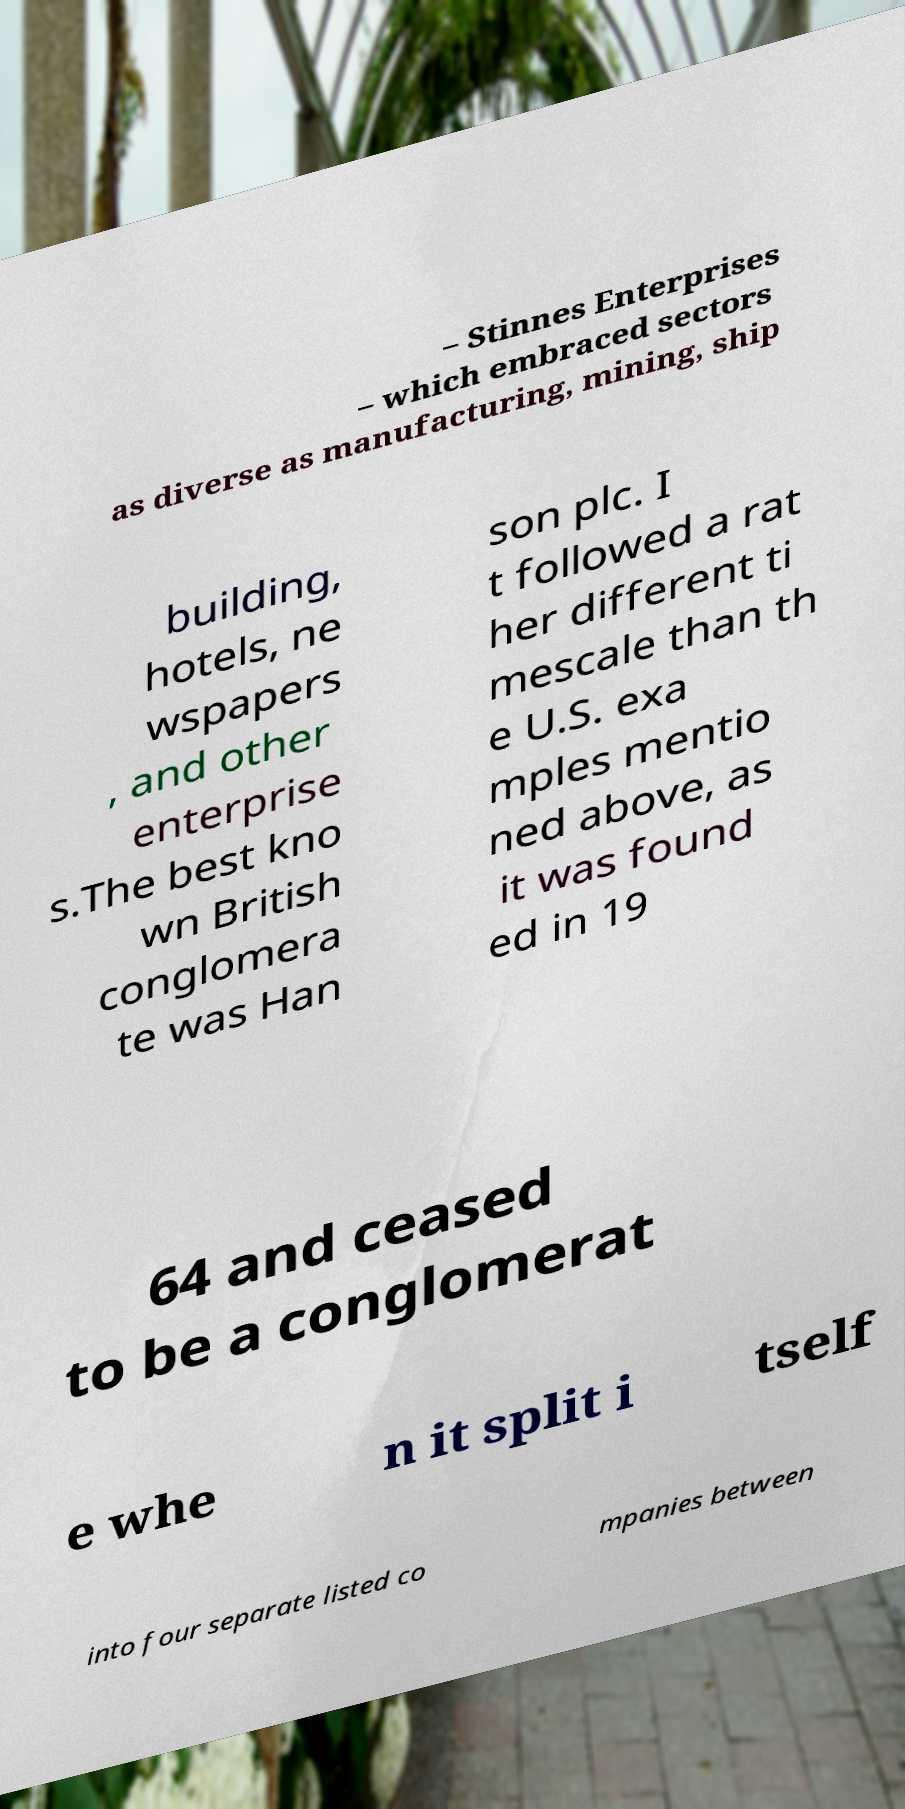There's text embedded in this image that I need extracted. Can you transcribe it verbatim? – Stinnes Enterprises – which embraced sectors as diverse as manufacturing, mining, ship building, hotels, ne wspapers , and other enterprise s.The best kno wn British conglomera te was Han son plc. I t followed a rat her different ti mescale than th e U.S. exa mples mentio ned above, as it was found ed in 19 64 and ceased to be a conglomerat e whe n it split i tself into four separate listed co mpanies between 